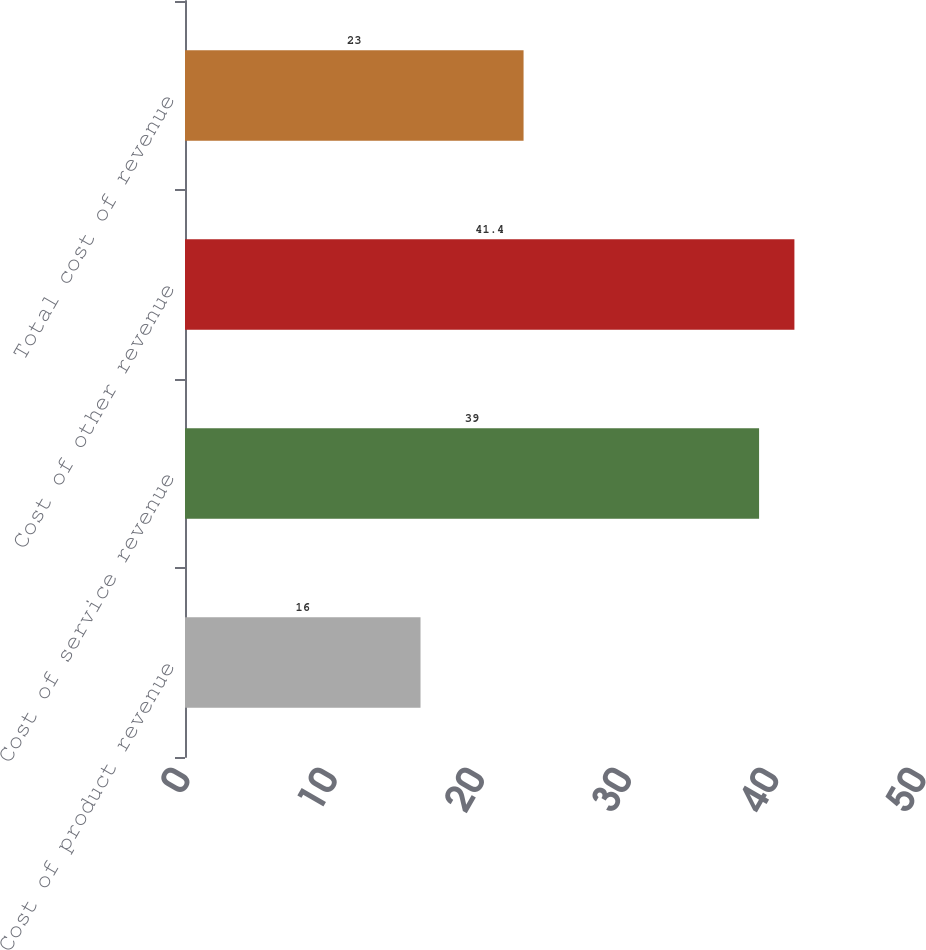Convert chart to OTSL. <chart><loc_0><loc_0><loc_500><loc_500><bar_chart><fcel>Cost of product revenue<fcel>Cost of service revenue<fcel>Cost of other revenue<fcel>Total cost of revenue<nl><fcel>16<fcel>39<fcel>41.4<fcel>23<nl></chart> 